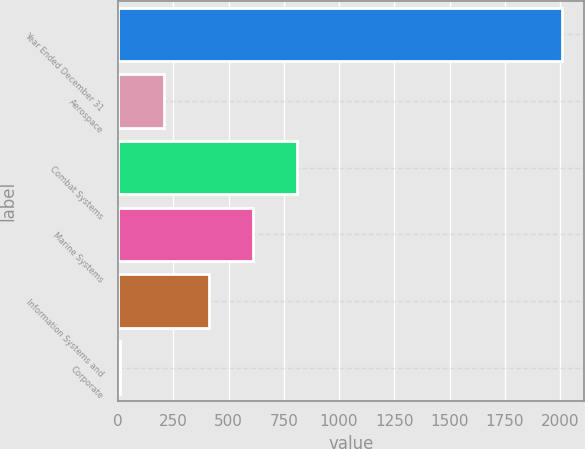<chart> <loc_0><loc_0><loc_500><loc_500><bar_chart><fcel>Year Ended December 31<fcel>Aerospace<fcel>Combat Systems<fcel>Marine Systems<fcel>Information Systems and<fcel>Corporate<nl><fcel>2010<fcel>210<fcel>810<fcel>610<fcel>410<fcel>10<nl></chart> 